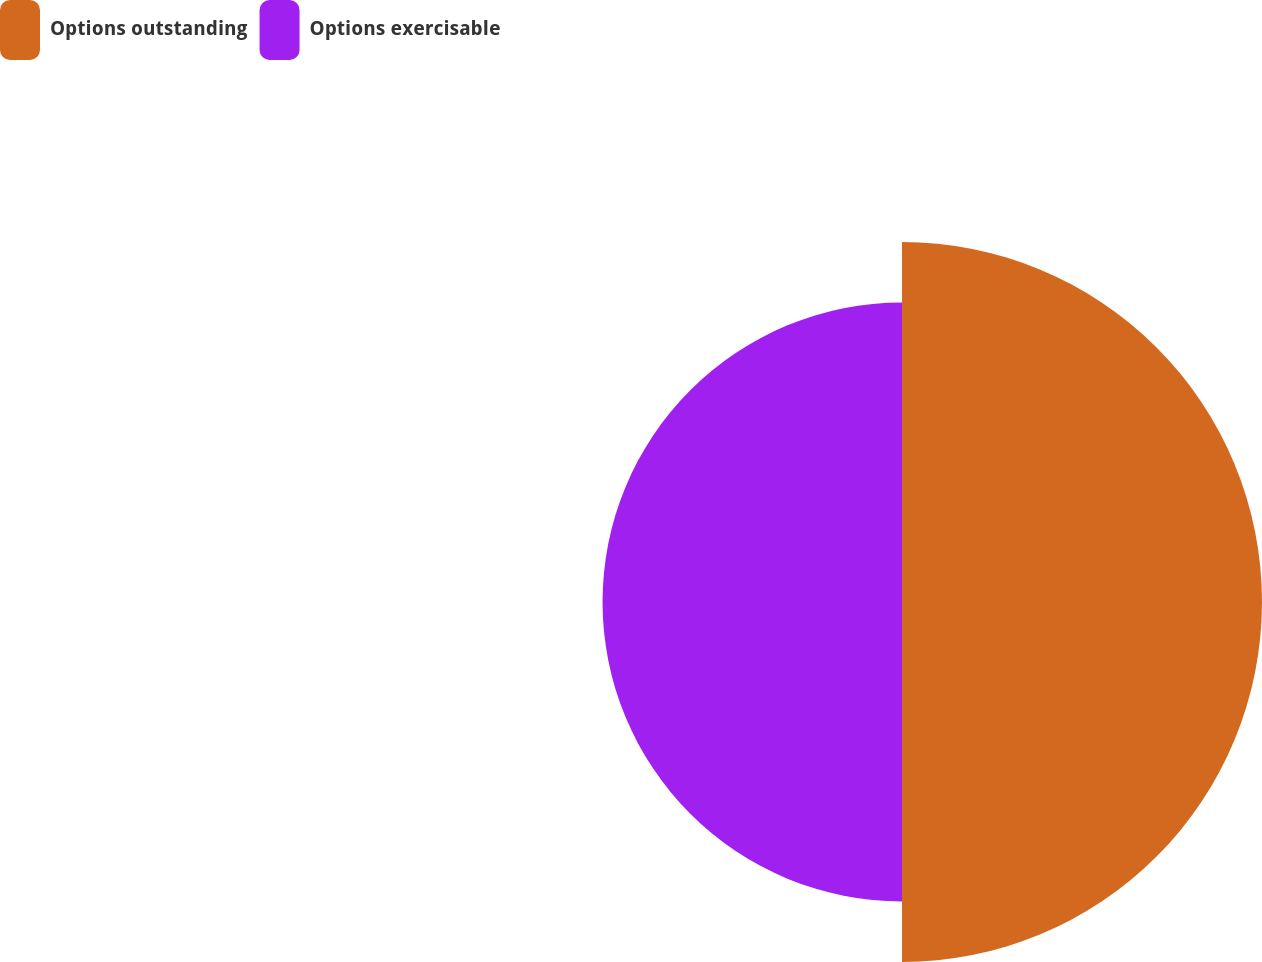<chart> <loc_0><loc_0><loc_500><loc_500><pie_chart><fcel>Options outstanding<fcel>Options exercisable<nl><fcel>54.59%<fcel>45.41%<nl></chart> 